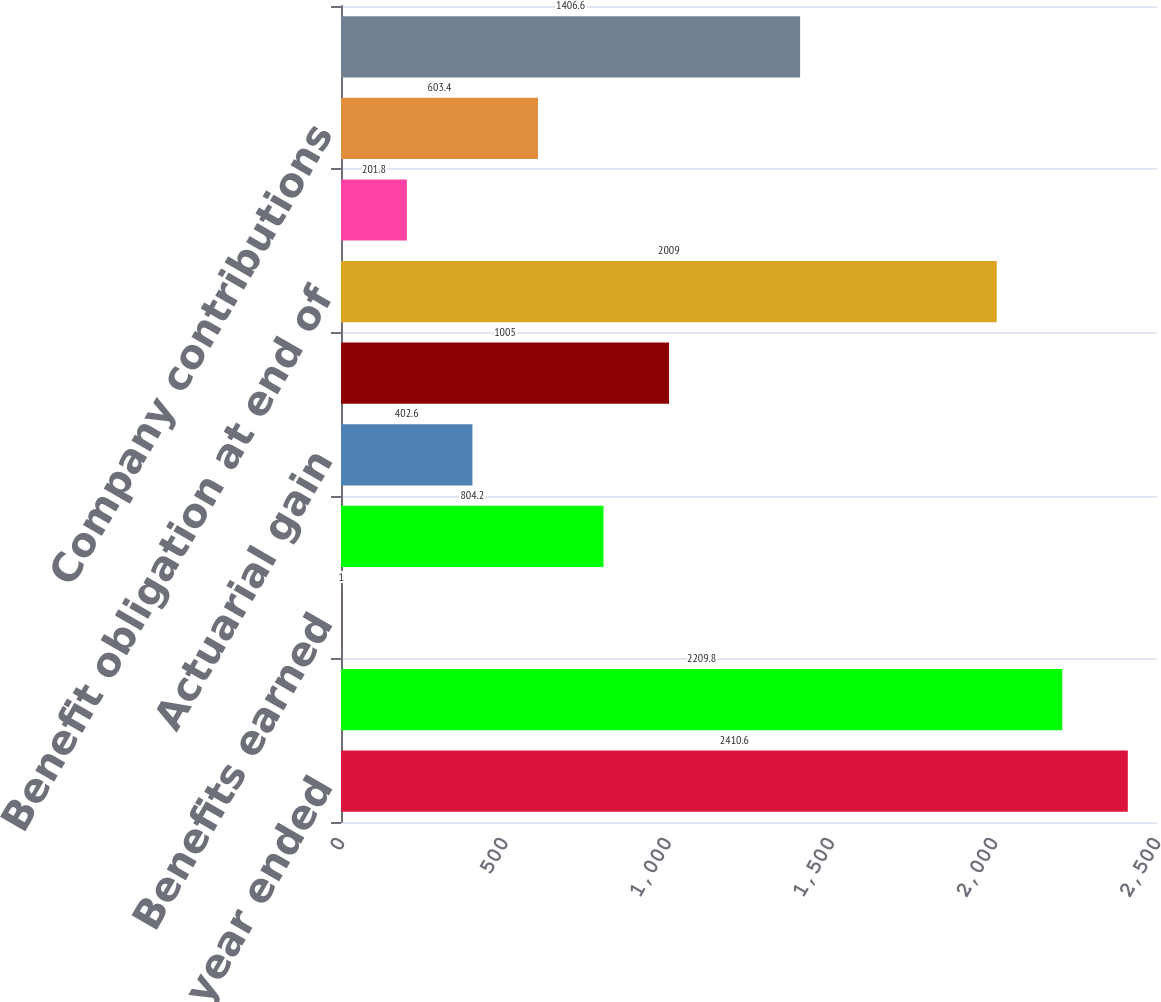Convert chart to OTSL. <chart><loc_0><loc_0><loc_500><loc_500><bar_chart><fcel>(at and for the year ended<fcel>Benefit obligation at<fcel>Benefits earned<fcel>Interest cost on benefit<fcel>Actuarial gain<fcel>Benefits paid<fcel>Benefit obligation at end of<fcel>Actual return on plan assets<fcel>Company contributions<fcel>Fair value of plan assets at<nl><fcel>2410.6<fcel>2209.8<fcel>1<fcel>804.2<fcel>402.6<fcel>1005<fcel>2009<fcel>201.8<fcel>603.4<fcel>1406.6<nl></chart> 